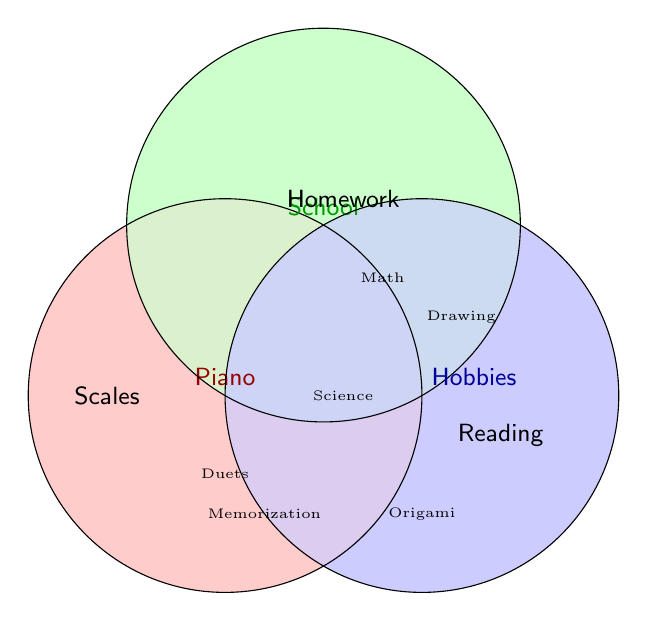What color represents the "Piano" practice time? The "Piano" practice time is represented by the red circle, as noted by the label "Piano" written in red.
Answer: Red What activity is related to both "Piano" and "School"? The area where the red and green circles overlap represents activities linked to both "Piano" and "School." This overlap includes the activities "Duets" and "Math."
Answer: Duets, Math Which circle represents "Hobbies"? The "Hobbies" practice time is represented by the blue circle, as indicated by the label "Hobbies" written in blue.
Answer: Blue Name an activity that is unique to "School." To find an activity unique to "School," look at the areas only covered by the green circle. "Homework" is such an activity.
Answer: Homework What are the activities that overlap between “School” and “Hobbies”? The overlapping area between the green and blue circles depicts activities linked to both "School" and "Hobbies." This includes "Science" and "Drawing."
Answer: Science, Drawing Is there any activity common to all three categories: "Piano," "School," and "Hobbies"? The area where all three circles overlap does not contain any listed activity, indicating no common activity for all three categories.
Answer: None Which activities are related only to "Piano" practice time? The activities located in the portion of the red circle that does not overlap with the other two circles are unique to "Piano." These are "Scales," "Sight-reading," and "Finger exercises."
Answer: Scales, Sight-reading, Finger exercises What activity is related to both "School" and "Hobbies" but not to "Piano"? Look for an area where only the green and blue circles overlap, excluding the red circle. "Origami" falls into this category.
Answer: Origami Which activities belong to all combinations including "Piano" but excluding "School"? Check the overlapping areas of the red circle with the blue but not the green circles. The activity "Reading" fits this description.
Answer: Reading Which activities belong to all combinations including "Piano" but excluding "Hobbies"? Examine the overlapping areas involving the red and green circles but not the blue circle. "Duets" and "Math" meet these criteria.
Answer: Duets, Math 